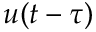Convert formula to latex. <formula><loc_0><loc_0><loc_500><loc_500>u ( t - \tau )</formula> 